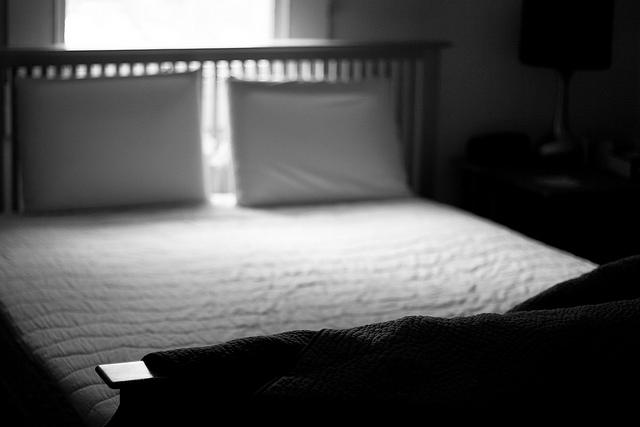What color is the photo?
Quick response, please. Black and white. Where is this picture taken?
Give a very brief answer. Bedroom. If the window in this picture is facing east, what time of day is it?
Concise answer only. Morning. How many pillows are on the bed?
Concise answer only. 2. 